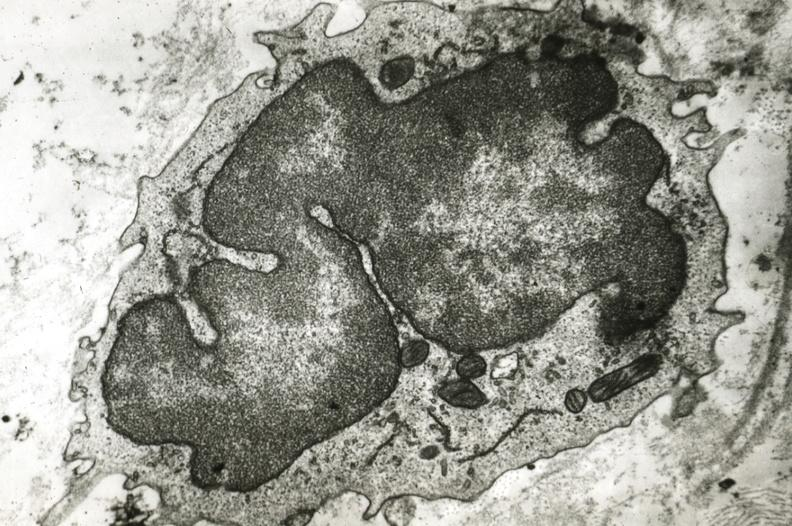what does this image show?
Answer the question using a single word or phrase. Monocyte in intima 